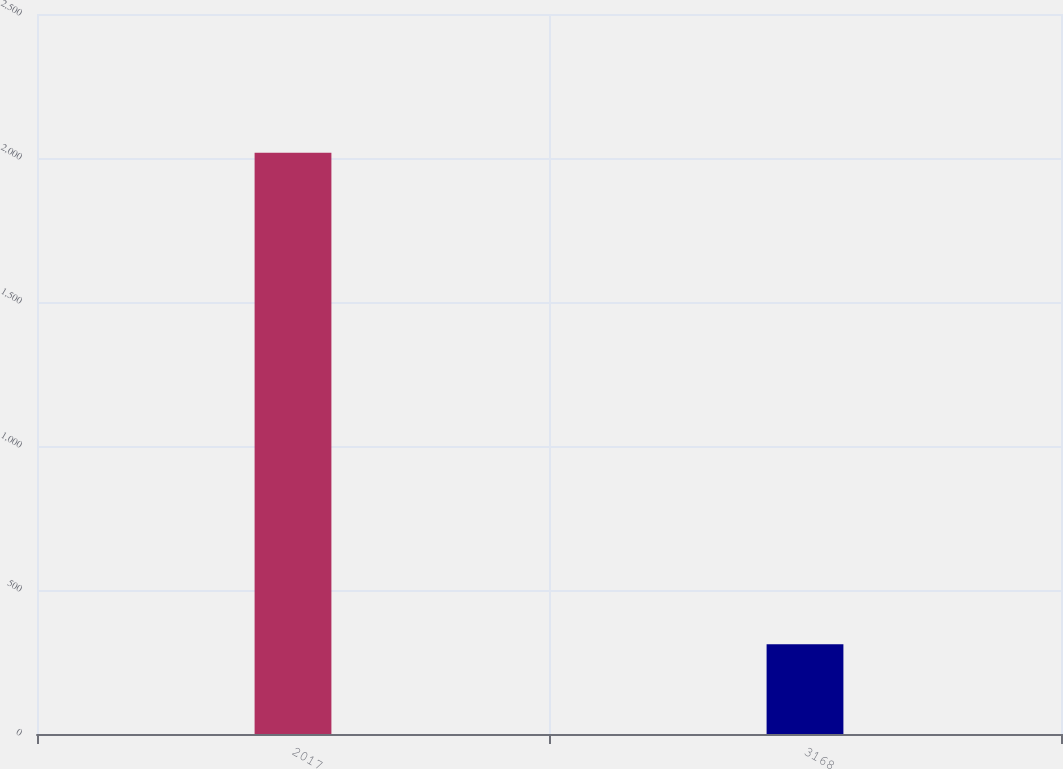Convert chart. <chart><loc_0><loc_0><loc_500><loc_500><bar_chart><fcel>2017<fcel>3168<nl><fcel>2018<fcel>311.5<nl></chart> 